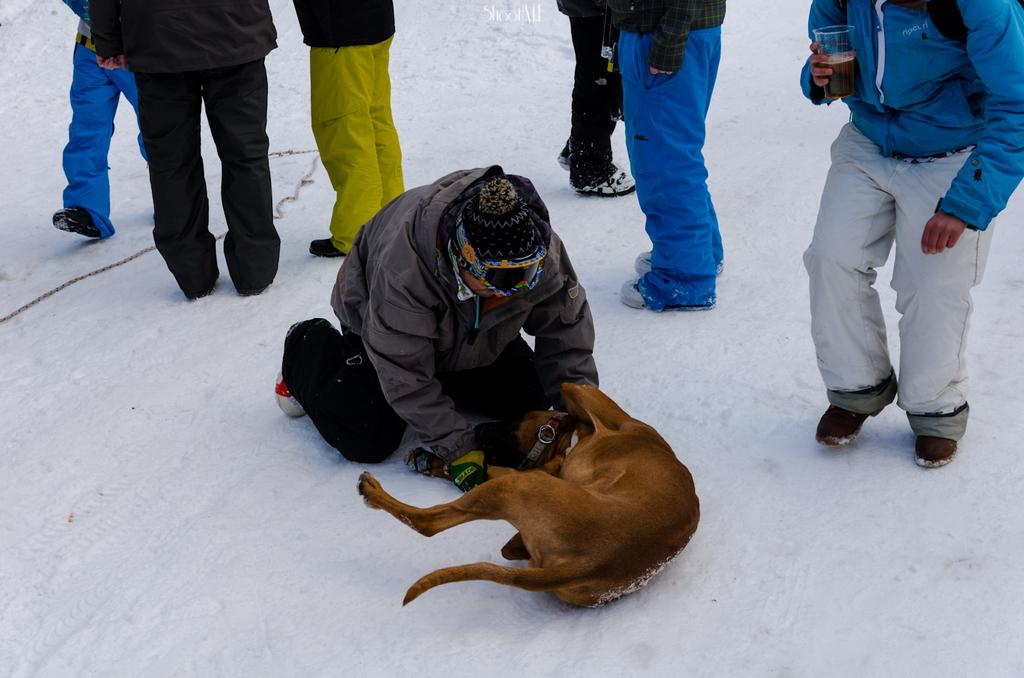What is the setting of the image? The people are standing on the snow in the image. Can you describe the relationship between the man and the dog in the image? There is a man with a dog in the image. What type of spoon is the man using to treat the disease in the image? There is no spoon or disease present in the image; it features people standing on the snow and a man with a dog. 